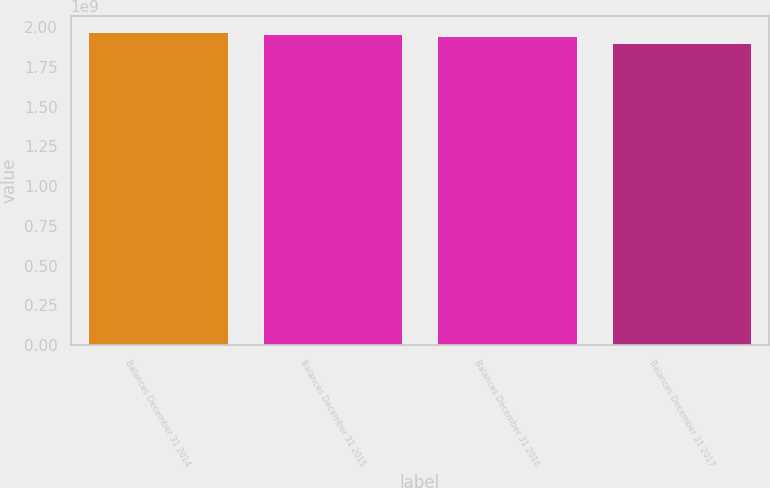Convert chart. <chart><loc_0><loc_0><loc_500><loc_500><bar_chart><fcel>Balances December 31 2014<fcel>Balances December 31 2015<fcel>Balances December 31 2016<fcel>Balances December 31 2017<nl><fcel>1.97147e+09<fcel>1.96006e+09<fcel>1.94327e+09<fcel>1.90126e+09<nl></chart> 